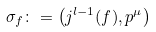<formula> <loc_0><loc_0><loc_500><loc_500>\sigma _ { f } \colon = \left ( j ^ { l - 1 } ( f ) , p ^ { \mu } \right )</formula> 